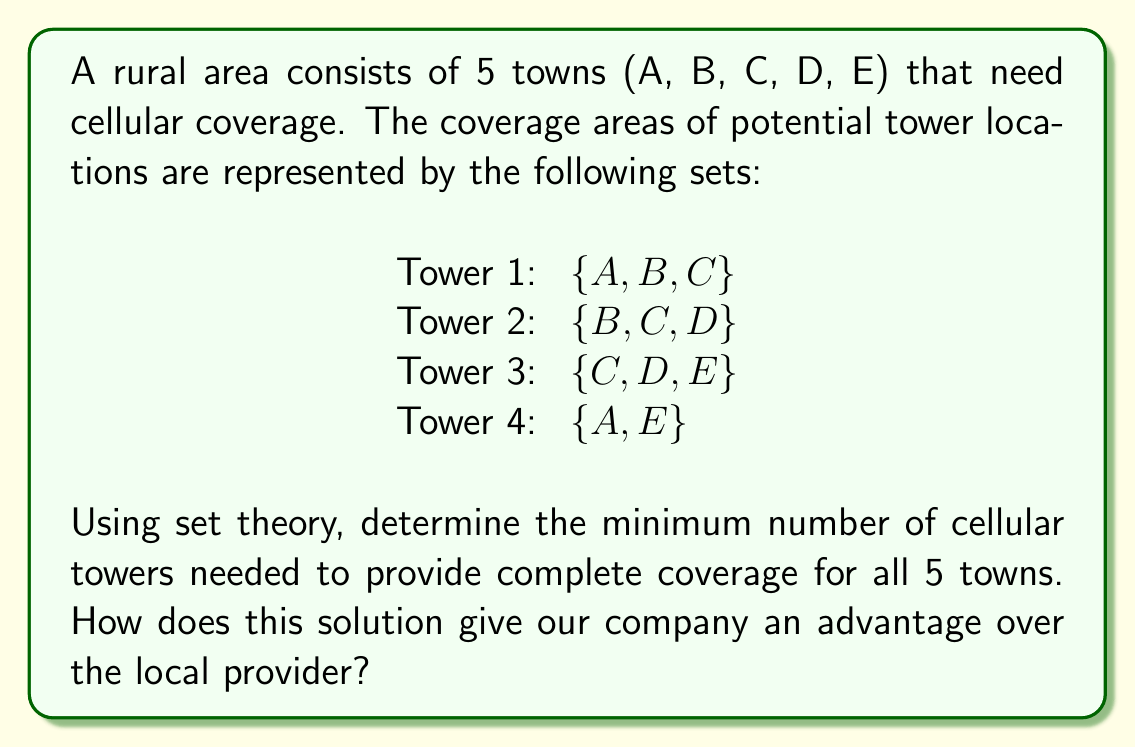Solve this math problem. To solve this problem, we'll use the set cover problem approach from set theory:

1) First, we need to ensure all towns are covered. Let's list out all towns:
   $U = \{A, B, C, D, E\}$

2) Now, let's analyze each tower's coverage:
   Tower 1: $\{A, B, C\}$
   Tower 2: $\{B, C, D\}$
   Tower 3: $\{C, D, E\}$
   Tower 4: $\{A, E\}$

3) We need to find the minimum number of these sets that, when combined, include all elements of $U$.

4) Let's start with Tower 1: $\{A, B, C\}$
   This covers 3 out of 5 towns.

5) To cover D and E, we can use Tower 3: $\{C, D, E\}$

6) The union of Tower 1 and Tower 3 gives us:
   $\{A, B, C\} \cup \{C, D, E\} = \{A, B, C, D, E\}$

7) This covers all towns with just 2 towers.

8) We can verify that no single tower covers all towns, so 2 is indeed the minimum.

This solution gives our company an advantage because:
a) It minimizes infrastructure costs by using the fewest towers possible.
b) It demonstrates our efficiency in network planning.
c) It shows our ability to provide complete coverage with minimal resources.
Answer: The minimum number of cellular towers needed for complete coverage is 2. 